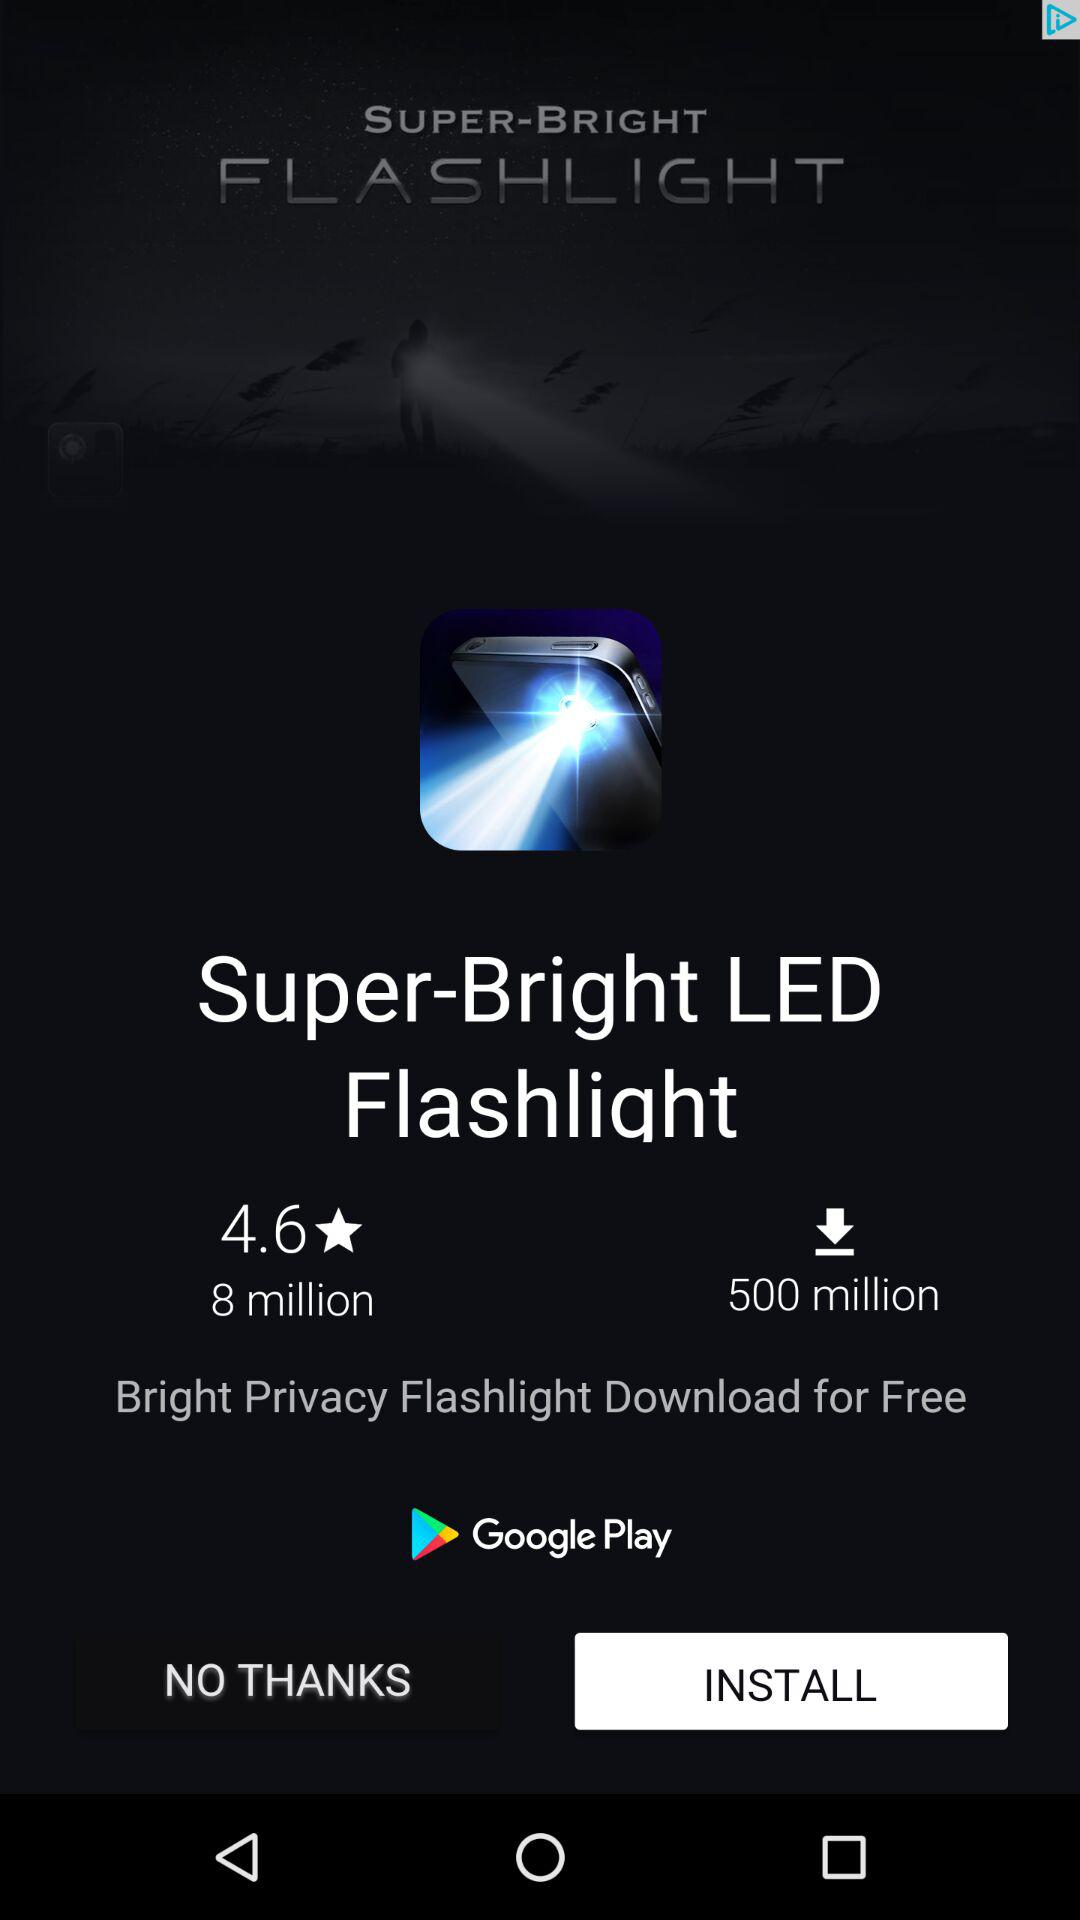How many more downloads does the Super-Bright LED Flashlight have than the Bright Privacy Flashlight?
Answer the question using a single word or phrase. 492 million 